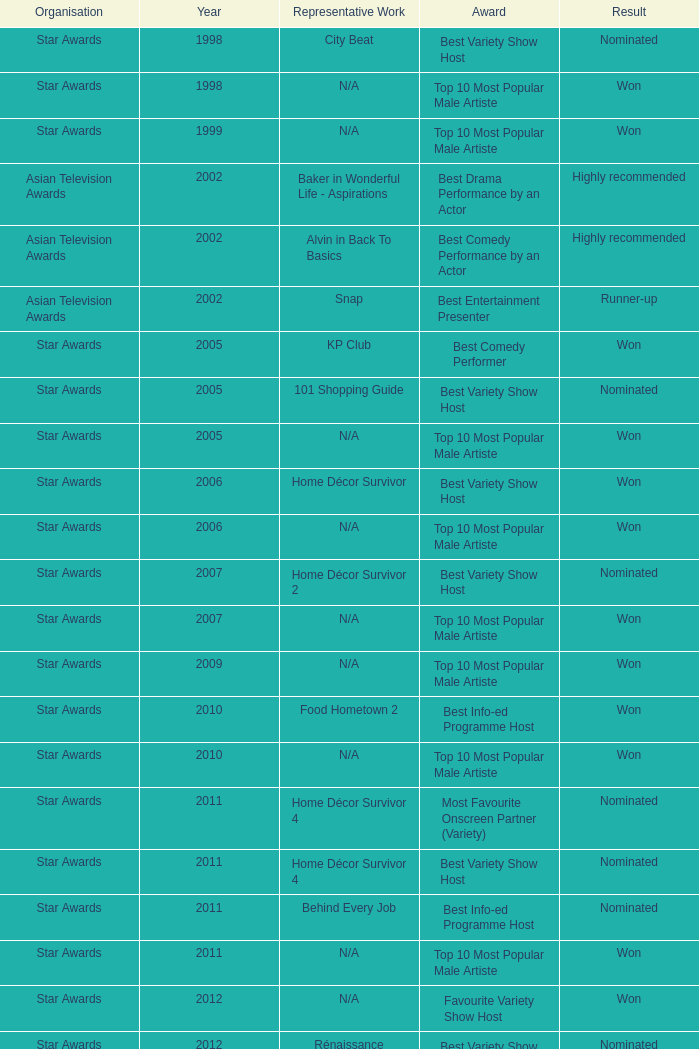What is the award for the Star Awards earlier than 2005 and the result is won? Top 10 Most Popular Male Artiste, Top 10 Most Popular Male Artiste. 